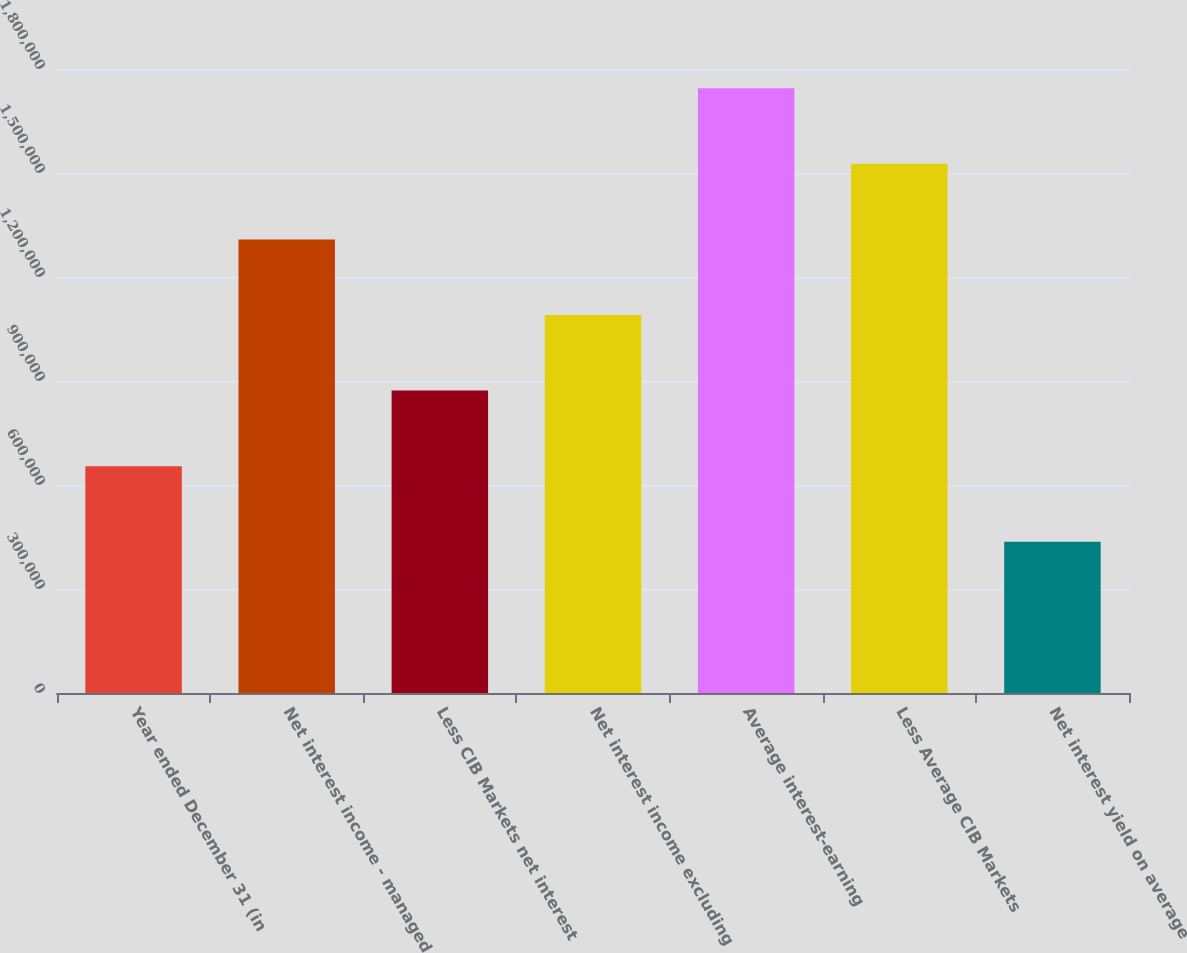<chart> <loc_0><loc_0><loc_500><loc_500><bar_chart><fcel>Year ended December 31 (in<fcel>Net interest income - managed<fcel>Less CIB Markets net interest<fcel>Net interest income excluding<fcel>Average interest-earning<fcel>Less Average CIB Markets<fcel>Net interest yield on average<nl><fcel>654178<fcel>1.30836e+06<fcel>872237<fcel>1.0903e+06<fcel>1.74447e+06<fcel>1.52641e+06<fcel>436119<nl></chart> 